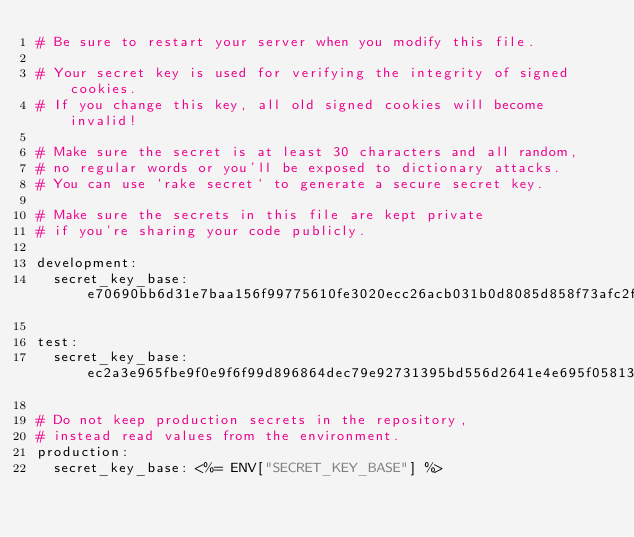<code> <loc_0><loc_0><loc_500><loc_500><_YAML_># Be sure to restart your server when you modify this file.

# Your secret key is used for verifying the integrity of signed cookies.
# If you change this key, all old signed cookies will become invalid!

# Make sure the secret is at least 30 characters and all random,
# no regular words or you'll be exposed to dictionary attacks.
# You can use `rake secret` to generate a secure secret key.

# Make sure the secrets in this file are kept private
# if you're sharing your code publicly.

development:
  secret_key_base: e70690bb6d31e7baa156f99775610fe3020ecc26acb031b0d8085d858f73afc2fd3a368e1376b757ff65c05d430abfbc799ec56097a4ac3d5224104d0abeecf1

test:
  secret_key_base: ec2a3e965fbe9f0e9f6f99d896864dec79e92731395bd556d2641e4e695f058139ff413c494aa4c66e8e848359f9f7788a05618c79675106eab50e47472b4479

# Do not keep production secrets in the repository,
# instead read values from the environment.
production:
  secret_key_base: <%= ENV["SECRET_KEY_BASE"] %>
</code> 